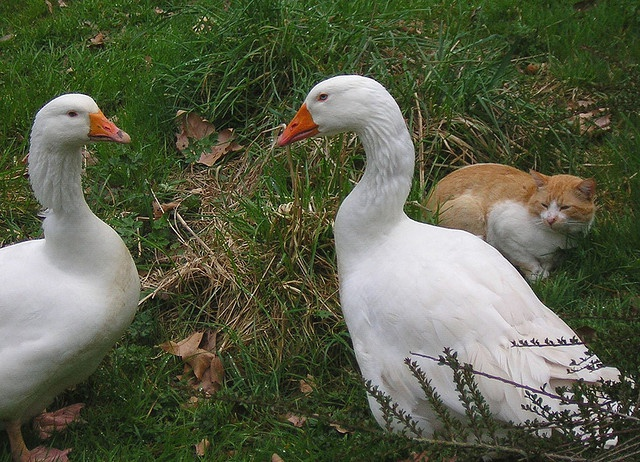Describe the objects in this image and their specific colors. I can see bird in darkgreen, lightgray, darkgray, gray, and black tones, bird in darkgreen, darkgray, lightgray, gray, and black tones, and cat in darkgreen, gray, darkgray, and tan tones in this image. 